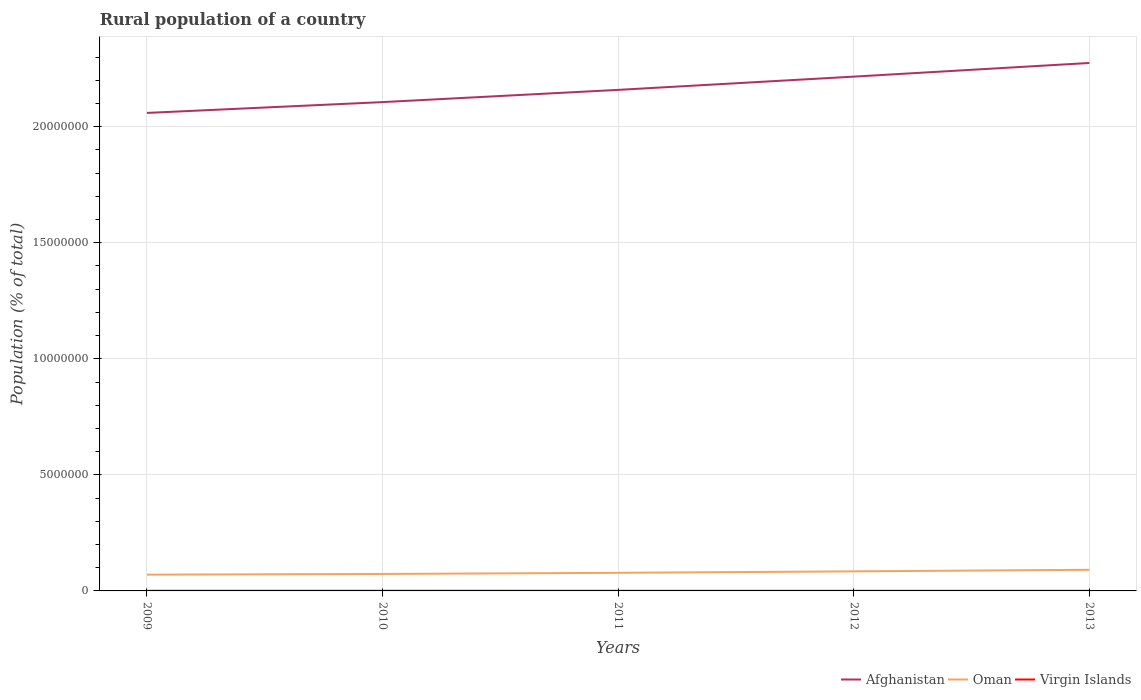Is the number of lines equal to the number of legend labels?
Ensure brevity in your answer.  Yes. Across all years, what is the maximum rural population in Afghanistan?
Give a very brief answer. 2.06e+07. What is the total rural population in Virgin Islands in the graph?
Offer a very short reply. 191. What is the difference between the highest and the second highest rural population in Virgin Islands?
Give a very brief answer. 785. Is the rural population in Afghanistan strictly greater than the rural population in Oman over the years?
Offer a terse response. No. Where does the legend appear in the graph?
Provide a succinct answer. Bottom right. How many legend labels are there?
Make the answer very short. 3. What is the title of the graph?
Your answer should be compact. Rural population of a country. Does "Uruguay" appear as one of the legend labels in the graph?
Your response must be concise. No. What is the label or title of the Y-axis?
Offer a terse response. Population (% of total). What is the Population (% of total) of Afghanistan in 2009?
Your answer should be very brief. 2.06e+07. What is the Population (% of total) in Oman in 2009?
Your response must be concise. 7.01e+05. What is the Population (% of total) in Virgin Islands in 2009?
Provide a short and direct response. 5955. What is the Population (% of total) in Afghanistan in 2010?
Keep it short and to the point. 2.11e+07. What is the Population (% of total) in Oman in 2010?
Keep it short and to the point. 7.31e+05. What is the Population (% of total) of Virgin Islands in 2010?
Give a very brief answer. 5745. What is the Population (% of total) in Afghanistan in 2011?
Your answer should be very brief. 2.16e+07. What is the Population (% of total) of Oman in 2011?
Ensure brevity in your answer.  7.80e+05. What is the Population (% of total) of Virgin Islands in 2011?
Your answer should be very brief. 5543. What is the Population (% of total) of Afghanistan in 2012?
Provide a succinct answer. 2.22e+07. What is the Population (% of total) of Oman in 2012?
Give a very brief answer. 8.44e+05. What is the Population (% of total) of Virgin Islands in 2012?
Your answer should be very brief. 5352. What is the Population (% of total) of Afghanistan in 2013?
Keep it short and to the point. 2.27e+07. What is the Population (% of total) of Oman in 2013?
Your answer should be compact. 9.10e+05. What is the Population (% of total) of Virgin Islands in 2013?
Provide a succinct answer. 5170. Across all years, what is the maximum Population (% of total) of Afghanistan?
Provide a succinct answer. 2.27e+07. Across all years, what is the maximum Population (% of total) in Oman?
Offer a very short reply. 9.10e+05. Across all years, what is the maximum Population (% of total) of Virgin Islands?
Offer a terse response. 5955. Across all years, what is the minimum Population (% of total) in Afghanistan?
Ensure brevity in your answer.  2.06e+07. Across all years, what is the minimum Population (% of total) in Oman?
Keep it short and to the point. 7.01e+05. Across all years, what is the minimum Population (% of total) of Virgin Islands?
Provide a succinct answer. 5170. What is the total Population (% of total) of Afghanistan in the graph?
Ensure brevity in your answer.  1.08e+08. What is the total Population (% of total) in Oman in the graph?
Ensure brevity in your answer.  3.97e+06. What is the total Population (% of total) of Virgin Islands in the graph?
Offer a terse response. 2.78e+04. What is the difference between the Population (% of total) of Afghanistan in 2009 and that in 2010?
Your response must be concise. -4.66e+05. What is the difference between the Population (% of total) in Oman in 2009 and that in 2010?
Keep it short and to the point. -3.03e+04. What is the difference between the Population (% of total) of Virgin Islands in 2009 and that in 2010?
Provide a succinct answer. 210. What is the difference between the Population (% of total) of Afghanistan in 2009 and that in 2011?
Offer a terse response. -9.93e+05. What is the difference between the Population (% of total) in Oman in 2009 and that in 2011?
Provide a succinct answer. -7.94e+04. What is the difference between the Population (% of total) in Virgin Islands in 2009 and that in 2011?
Offer a very short reply. 412. What is the difference between the Population (% of total) of Afghanistan in 2009 and that in 2012?
Keep it short and to the point. -1.56e+06. What is the difference between the Population (% of total) in Oman in 2009 and that in 2012?
Make the answer very short. -1.43e+05. What is the difference between the Population (% of total) of Virgin Islands in 2009 and that in 2012?
Offer a very short reply. 603. What is the difference between the Population (% of total) in Afghanistan in 2009 and that in 2013?
Give a very brief answer. -2.15e+06. What is the difference between the Population (% of total) in Oman in 2009 and that in 2013?
Your answer should be very brief. -2.09e+05. What is the difference between the Population (% of total) in Virgin Islands in 2009 and that in 2013?
Ensure brevity in your answer.  785. What is the difference between the Population (% of total) in Afghanistan in 2010 and that in 2011?
Keep it short and to the point. -5.27e+05. What is the difference between the Population (% of total) of Oman in 2010 and that in 2011?
Keep it short and to the point. -4.91e+04. What is the difference between the Population (% of total) of Virgin Islands in 2010 and that in 2011?
Keep it short and to the point. 202. What is the difference between the Population (% of total) of Afghanistan in 2010 and that in 2012?
Offer a very short reply. -1.10e+06. What is the difference between the Population (% of total) of Oman in 2010 and that in 2012?
Provide a short and direct response. -1.12e+05. What is the difference between the Population (% of total) in Virgin Islands in 2010 and that in 2012?
Give a very brief answer. 393. What is the difference between the Population (% of total) of Afghanistan in 2010 and that in 2013?
Your answer should be very brief. -1.69e+06. What is the difference between the Population (% of total) in Oman in 2010 and that in 2013?
Offer a very short reply. -1.79e+05. What is the difference between the Population (% of total) in Virgin Islands in 2010 and that in 2013?
Your response must be concise. 575. What is the difference between the Population (% of total) in Afghanistan in 2011 and that in 2012?
Offer a terse response. -5.70e+05. What is the difference between the Population (% of total) in Oman in 2011 and that in 2012?
Your answer should be compact. -6.33e+04. What is the difference between the Population (% of total) in Virgin Islands in 2011 and that in 2012?
Make the answer very short. 191. What is the difference between the Population (% of total) of Afghanistan in 2011 and that in 2013?
Offer a very short reply. -1.16e+06. What is the difference between the Population (% of total) of Oman in 2011 and that in 2013?
Your response must be concise. -1.30e+05. What is the difference between the Population (% of total) in Virgin Islands in 2011 and that in 2013?
Provide a succinct answer. 373. What is the difference between the Population (% of total) in Afghanistan in 2012 and that in 2013?
Ensure brevity in your answer.  -5.89e+05. What is the difference between the Population (% of total) of Oman in 2012 and that in 2013?
Keep it short and to the point. -6.67e+04. What is the difference between the Population (% of total) in Virgin Islands in 2012 and that in 2013?
Offer a very short reply. 182. What is the difference between the Population (% of total) in Afghanistan in 2009 and the Population (% of total) in Oman in 2010?
Provide a succinct answer. 1.99e+07. What is the difference between the Population (% of total) in Afghanistan in 2009 and the Population (% of total) in Virgin Islands in 2010?
Offer a terse response. 2.06e+07. What is the difference between the Population (% of total) in Oman in 2009 and the Population (% of total) in Virgin Islands in 2010?
Ensure brevity in your answer.  6.95e+05. What is the difference between the Population (% of total) of Afghanistan in 2009 and the Population (% of total) of Oman in 2011?
Keep it short and to the point. 1.98e+07. What is the difference between the Population (% of total) in Afghanistan in 2009 and the Population (% of total) in Virgin Islands in 2011?
Keep it short and to the point. 2.06e+07. What is the difference between the Population (% of total) in Oman in 2009 and the Population (% of total) in Virgin Islands in 2011?
Provide a succinct answer. 6.95e+05. What is the difference between the Population (% of total) in Afghanistan in 2009 and the Population (% of total) in Oman in 2012?
Provide a succinct answer. 1.97e+07. What is the difference between the Population (% of total) of Afghanistan in 2009 and the Population (% of total) of Virgin Islands in 2012?
Provide a succinct answer. 2.06e+07. What is the difference between the Population (% of total) of Oman in 2009 and the Population (% of total) of Virgin Islands in 2012?
Your answer should be compact. 6.96e+05. What is the difference between the Population (% of total) in Afghanistan in 2009 and the Population (% of total) in Oman in 2013?
Your answer should be very brief. 1.97e+07. What is the difference between the Population (% of total) of Afghanistan in 2009 and the Population (% of total) of Virgin Islands in 2013?
Provide a short and direct response. 2.06e+07. What is the difference between the Population (% of total) of Oman in 2009 and the Population (% of total) of Virgin Islands in 2013?
Make the answer very short. 6.96e+05. What is the difference between the Population (% of total) in Afghanistan in 2010 and the Population (% of total) in Oman in 2011?
Offer a very short reply. 2.03e+07. What is the difference between the Population (% of total) in Afghanistan in 2010 and the Population (% of total) in Virgin Islands in 2011?
Your response must be concise. 2.11e+07. What is the difference between the Population (% of total) in Oman in 2010 and the Population (% of total) in Virgin Islands in 2011?
Give a very brief answer. 7.26e+05. What is the difference between the Population (% of total) of Afghanistan in 2010 and the Population (% of total) of Oman in 2012?
Your response must be concise. 2.02e+07. What is the difference between the Population (% of total) of Afghanistan in 2010 and the Population (% of total) of Virgin Islands in 2012?
Your response must be concise. 2.11e+07. What is the difference between the Population (% of total) in Oman in 2010 and the Population (% of total) in Virgin Islands in 2012?
Give a very brief answer. 7.26e+05. What is the difference between the Population (% of total) of Afghanistan in 2010 and the Population (% of total) of Oman in 2013?
Provide a succinct answer. 2.01e+07. What is the difference between the Population (% of total) of Afghanistan in 2010 and the Population (% of total) of Virgin Islands in 2013?
Your answer should be very brief. 2.11e+07. What is the difference between the Population (% of total) of Oman in 2010 and the Population (% of total) of Virgin Islands in 2013?
Your answer should be very brief. 7.26e+05. What is the difference between the Population (% of total) in Afghanistan in 2011 and the Population (% of total) in Oman in 2012?
Keep it short and to the point. 2.07e+07. What is the difference between the Population (% of total) in Afghanistan in 2011 and the Population (% of total) in Virgin Islands in 2012?
Your answer should be very brief. 2.16e+07. What is the difference between the Population (% of total) in Oman in 2011 and the Population (% of total) in Virgin Islands in 2012?
Offer a very short reply. 7.75e+05. What is the difference between the Population (% of total) in Afghanistan in 2011 and the Population (% of total) in Oman in 2013?
Provide a succinct answer. 2.07e+07. What is the difference between the Population (% of total) in Afghanistan in 2011 and the Population (% of total) in Virgin Islands in 2013?
Provide a short and direct response. 2.16e+07. What is the difference between the Population (% of total) in Oman in 2011 and the Population (% of total) in Virgin Islands in 2013?
Offer a very short reply. 7.75e+05. What is the difference between the Population (% of total) of Afghanistan in 2012 and the Population (% of total) of Oman in 2013?
Provide a succinct answer. 2.12e+07. What is the difference between the Population (% of total) in Afghanistan in 2012 and the Population (% of total) in Virgin Islands in 2013?
Provide a short and direct response. 2.22e+07. What is the difference between the Population (% of total) in Oman in 2012 and the Population (% of total) in Virgin Islands in 2013?
Ensure brevity in your answer.  8.38e+05. What is the average Population (% of total) in Afghanistan per year?
Your answer should be compact. 2.16e+07. What is the average Population (% of total) in Oman per year?
Provide a short and direct response. 7.93e+05. What is the average Population (% of total) of Virgin Islands per year?
Make the answer very short. 5553. In the year 2009, what is the difference between the Population (% of total) in Afghanistan and Population (% of total) in Oman?
Provide a short and direct response. 1.99e+07. In the year 2009, what is the difference between the Population (% of total) in Afghanistan and Population (% of total) in Virgin Islands?
Your answer should be compact. 2.06e+07. In the year 2009, what is the difference between the Population (% of total) of Oman and Population (% of total) of Virgin Islands?
Your response must be concise. 6.95e+05. In the year 2010, what is the difference between the Population (% of total) in Afghanistan and Population (% of total) in Oman?
Offer a very short reply. 2.03e+07. In the year 2010, what is the difference between the Population (% of total) of Afghanistan and Population (% of total) of Virgin Islands?
Your answer should be very brief. 2.11e+07. In the year 2010, what is the difference between the Population (% of total) in Oman and Population (% of total) in Virgin Islands?
Your answer should be very brief. 7.25e+05. In the year 2011, what is the difference between the Population (% of total) of Afghanistan and Population (% of total) of Oman?
Ensure brevity in your answer.  2.08e+07. In the year 2011, what is the difference between the Population (% of total) of Afghanistan and Population (% of total) of Virgin Islands?
Ensure brevity in your answer.  2.16e+07. In the year 2011, what is the difference between the Population (% of total) in Oman and Population (% of total) in Virgin Islands?
Offer a very short reply. 7.75e+05. In the year 2012, what is the difference between the Population (% of total) in Afghanistan and Population (% of total) in Oman?
Provide a short and direct response. 2.13e+07. In the year 2012, what is the difference between the Population (% of total) in Afghanistan and Population (% of total) in Virgin Islands?
Make the answer very short. 2.22e+07. In the year 2012, what is the difference between the Population (% of total) in Oman and Population (% of total) in Virgin Islands?
Your answer should be compact. 8.38e+05. In the year 2013, what is the difference between the Population (% of total) of Afghanistan and Population (% of total) of Oman?
Give a very brief answer. 2.18e+07. In the year 2013, what is the difference between the Population (% of total) of Afghanistan and Population (% of total) of Virgin Islands?
Ensure brevity in your answer.  2.27e+07. In the year 2013, what is the difference between the Population (% of total) in Oman and Population (% of total) in Virgin Islands?
Your response must be concise. 9.05e+05. What is the ratio of the Population (% of total) in Afghanistan in 2009 to that in 2010?
Your answer should be compact. 0.98. What is the ratio of the Population (% of total) in Oman in 2009 to that in 2010?
Your answer should be compact. 0.96. What is the ratio of the Population (% of total) of Virgin Islands in 2009 to that in 2010?
Offer a very short reply. 1.04. What is the ratio of the Population (% of total) in Afghanistan in 2009 to that in 2011?
Keep it short and to the point. 0.95. What is the ratio of the Population (% of total) in Oman in 2009 to that in 2011?
Your answer should be compact. 0.9. What is the ratio of the Population (% of total) in Virgin Islands in 2009 to that in 2011?
Provide a short and direct response. 1.07. What is the ratio of the Population (% of total) in Afghanistan in 2009 to that in 2012?
Make the answer very short. 0.93. What is the ratio of the Population (% of total) in Oman in 2009 to that in 2012?
Your response must be concise. 0.83. What is the ratio of the Population (% of total) in Virgin Islands in 2009 to that in 2012?
Your response must be concise. 1.11. What is the ratio of the Population (% of total) of Afghanistan in 2009 to that in 2013?
Your response must be concise. 0.91. What is the ratio of the Population (% of total) of Oman in 2009 to that in 2013?
Your answer should be compact. 0.77. What is the ratio of the Population (% of total) in Virgin Islands in 2009 to that in 2013?
Ensure brevity in your answer.  1.15. What is the ratio of the Population (% of total) of Afghanistan in 2010 to that in 2011?
Offer a terse response. 0.98. What is the ratio of the Population (% of total) of Oman in 2010 to that in 2011?
Your answer should be compact. 0.94. What is the ratio of the Population (% of total) in Virgin Islands in 2010 to that in 2011?
Offer a very short reply. 1.04. What is the ratio of the Population (% of total) in Afghanistan in 2010 to that in 2012?
Give a very brief answer. 0.95. What is the ratio of the Population (% of total) of Oman in 2010 to that in 2012?
Make the answer very short. 0.87. What is the ratio of the Population (% of total) of Virgin Islands in 2010 to that in 2012?
Offer a terse response. 1.07. What is the ratio of the Population (% of total) in Afghanistan in 2010 to that in 2013?
Give a very brief answer. 0.93. What is the ratio of the Population (% of total) in Oman in 2010 to that in 2013?
Your answer should be compact. 0.8. What is the ratio of the Population (% of total) of Virgin Islands in 2010 to that in 2013?
Provide a short and direct response. 1.11. What is the ratio of the Population (% of total) of Afghanistan in 2011 to that in 2012?
Provide a succinct answer. 0.97. What is the ratio of the Population (% of total) in Oman in 2011 to that in 2012?
Your answer should be very brief. 0.93. What is the ratio of the Population (% of total) of Virgin Islands in 2011 to that in 2012?
Make the answer very short. 1.04. What is the ratio of the Population (% of total) of Afghanistan in 2011 to that in 2013?
Keep it short and to the point. 0.95. What is the ratio of the Population (% of total) of Oman in 2011 to that in 2013?
Your answer should be very brief. 0.86. What is the ratio of the Population (% of total) in Virgin Islands in 2011 to that in 2013?
Keep it short and to the point. 1.07. What is the ratio of the Population (% of total) in Afghanistan in 2012 to that in 2013?
Give a very brief answer. 0.97. What is the ratio of the Population (% of total) in Oman in 2012 to that in 2013?
Give a very brief answer. 0.93. What is the ratio of the Population (% of total) of Virgin Islands in 2012 to that in 2013?
Offer a terse response. 1.04. What is the difference between the highest and the second highest Population (% of total) of Afghanistan?
Your answer should be very brief. 5.89e+05. What is the difference between the highest and the second highest Population (% of total) in Oman?
Provide a short and direct response. 6.67e+04. What is the difference between the highest and the second highest Population (% of total) of Virgin Islands?
Provide a succinct answer. 210. What is the difference between the highest and the lowest Population (% of total) in Afghanistan?
Make the answer very short. 2.15e+06. What is the difference between the highest and the lowest Population (% of total) in Oman?
Keep it short and to the point. 2.09e+05. What is the difference between the highest and the lowest Population (% of total) in Virgin Islands?
Provide a short and direct response. 785. 